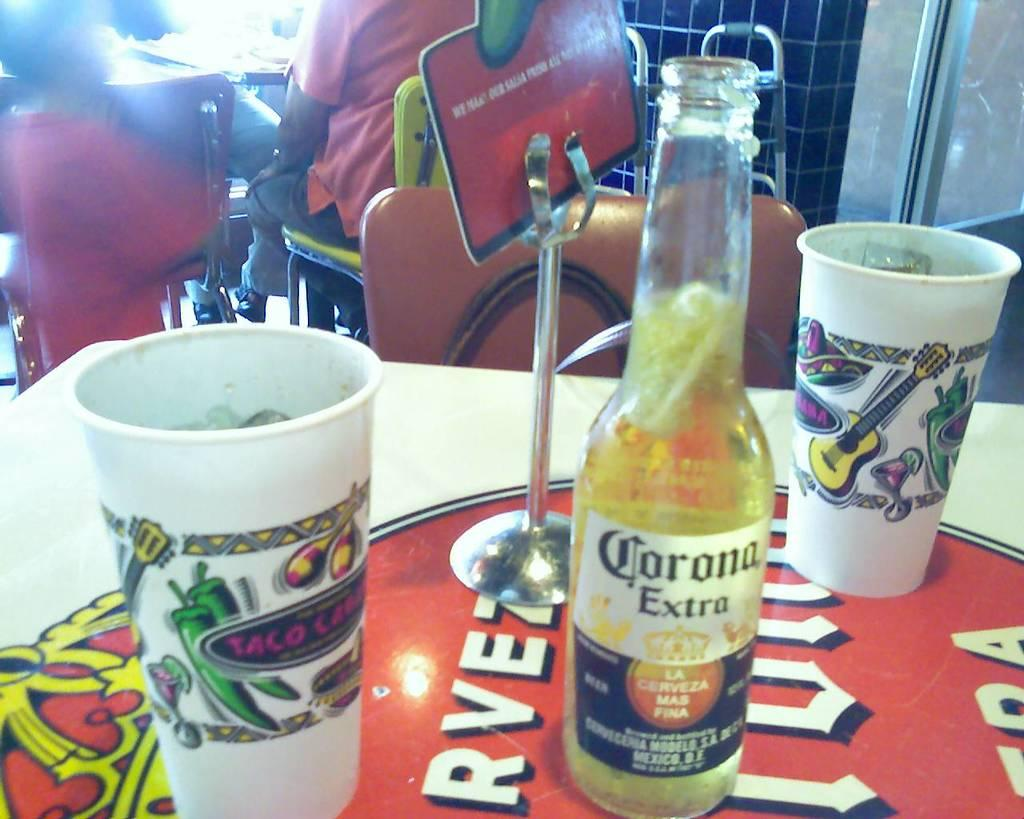What piece of furniture is present in the image? There is a table in the image. What objects are placed on the table? There are two glasses and a bottle on the table. Is there any additional structure on the table? Yes, there is a stand on the table. What type of jewel is displayed on the stand in the image? There is no jewel present in the image; the stand is empty. How does the development of the table contribute to the overall design of the image? The development of the table does not contribute to the overall design of the image, as the table is a simple piece of furniture with no apparent design elements. 